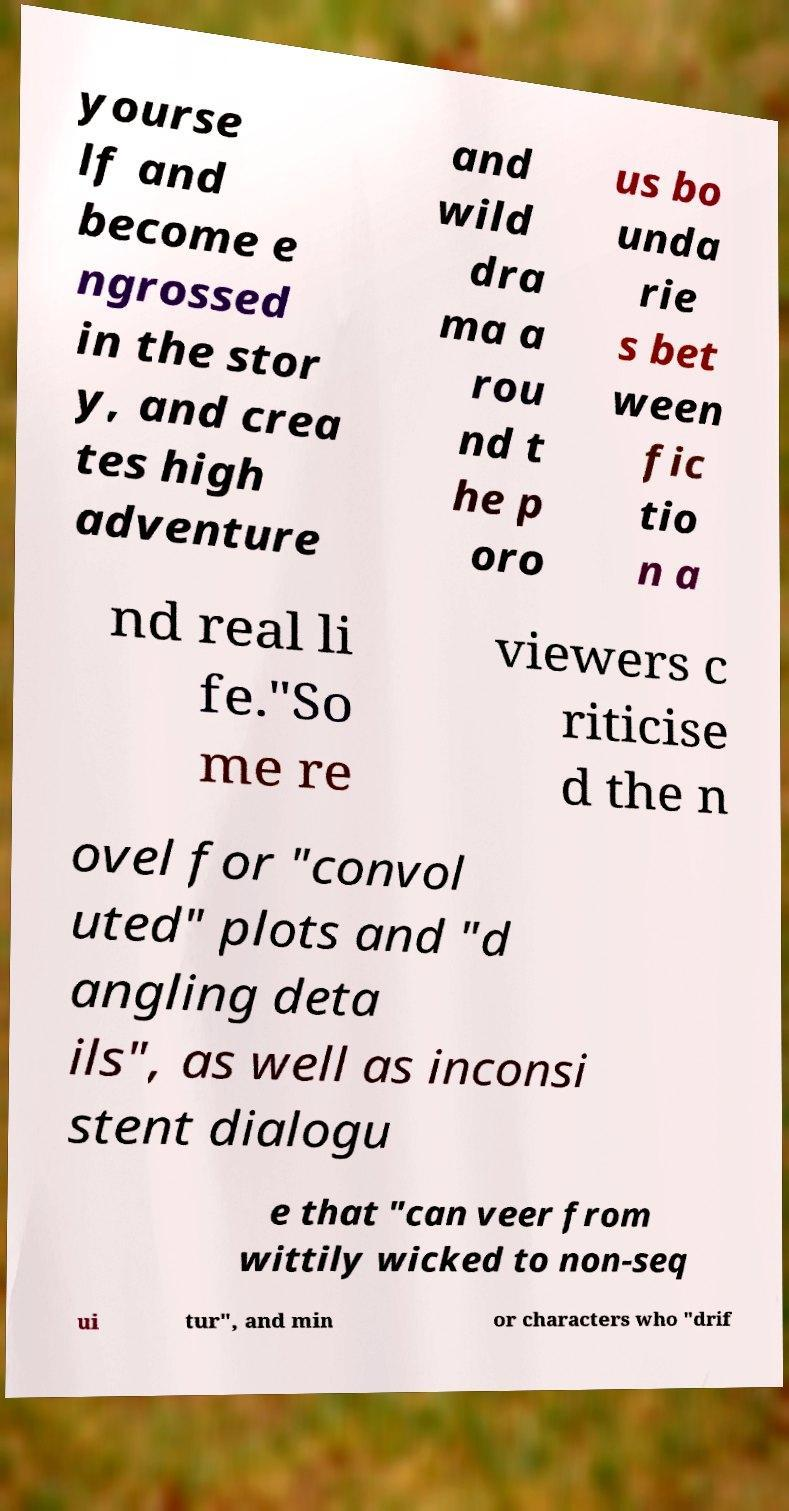Could you assist in decoding the text presented in this image and type it out clearly? yourse lf and become e ngrossed in the stor y, and crea tes high adventure and wild dra ma a rou nd t he p oro us bo unda rie s bet ween fic tio n a nd real li fe."So me re viewers c riticise d the n ovel for "convol uted" plots and "d angling deta ils", as well as inconsi stent dialogu e that "can veer from wittily wicked to non-seq ui tur", and min or characters who "drif 